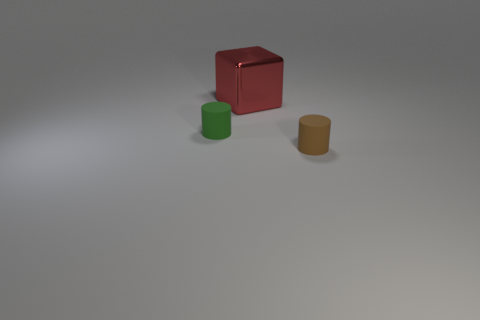Add 2 big brown spheres. How many objects exist? 5 Subtract all cylinders. How many objects are left? 1 Subtract 0 gray spheres. How many objects are left? 3 Subtract all small gray rubber cylinders. Subtract all red metal objects. How many objects are left? 2 Add 3 cylinders. How many cylinders are left? 5 Add 1 big red shiny things. How many big red shiny things exist? 2 